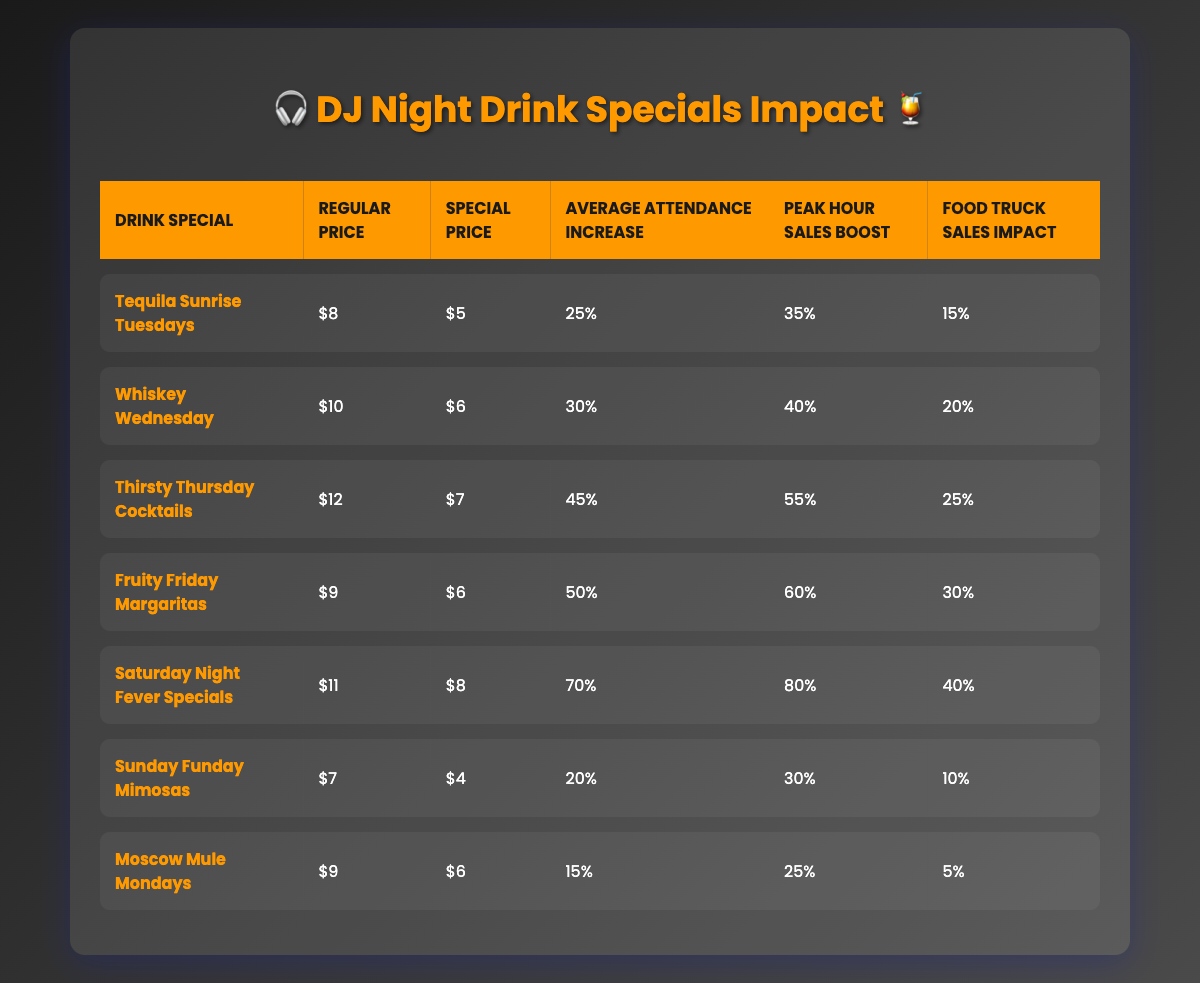What is the special price for "Fruity Friday Margaritas"? The table lists the special price for "Fruity Friday Margaritas" under the "Special Price" column, which is $6.
Answer: $6 Which drink special has the highest average attendance increase? Looking at the "Average Attendance Increase" column, "Saturday Night Fever Specials" has the highest percentage at 70%.
Answer: 70% What is the food truck sales impact for "Whiskey Wednesday"? The "Food Truck Sales Impact" column indicates that the impact for "Whiskey Wednesday" is 20%.
Answer: 20% How much do "Tequila Sunrise Tuesdays" and "Sunday Funday Mimosas" cost in total at their special prices? The special prices are $5 for "Tequila Sunrise Tuesdays" and $4 for "Sunday Funday Mimosas". Summing these gives $5 + $4 = $9.
Answer: $9 Is the peak hour sales boost for "Moscow Mule Mondays" higher than for "Tequila Sunrise Tuesdays"? Comparing the values in the "Peak Hour Sales Boost" column, "Moscow Mule Mondays" has a boost of 25%, while "Tequila Sunrise Tuesdays" has 35%. Since 25% is less than 35%, the statement is false.
Answer: No What is the difference in peak hour sales boost between the highest and lowest drink specials? The highest boost is from "Saturday Night Fever Specials" at 80%, and the lowest is "Moscow Mule Mondays" at 25%. The difference is 80% - 25% = 55%.
Answer: 55% For which drink special is the food truck sales impact equal to its average attendance increase? Looking at the "Food Truck Sales Impact" and "Average Attendance Increase" columns, only "Sunday Funday Mimosas" has a food truck sales impact of 10%, and an average attendance increase of 20%, indicating none are equal.
Answer: None On average, how much do drinks cost during the specials? Calculating the average of the special prices: $5, $6, $7, $6, $8, $4, and $6 gives a total of $42. There are 7 specials, so the average is $42 / 7 = $6.
Answer: $6 Which day has the largest difference between regular price and special price? Calculating the differences: Tequila Sunrise (3), Whiskey Wednesday (4), Thirsty Thursday (5), Fruity Friday (3), Saturday Night (3), Sunday Funday (3), Moscow Mule (3). The largest difference is for Thirsty Thursday Cocktails, which is $5.
Answer: $5 What percentage increase in attendance would you expect if drinks were priced at special prices for "Whiskey Wednesday" instead of regular prices? The average attendance increase for "Whiskey Wednesday" is 30%. Therefore, you would expect a 30% increase in attendance.
Answer: 30% 